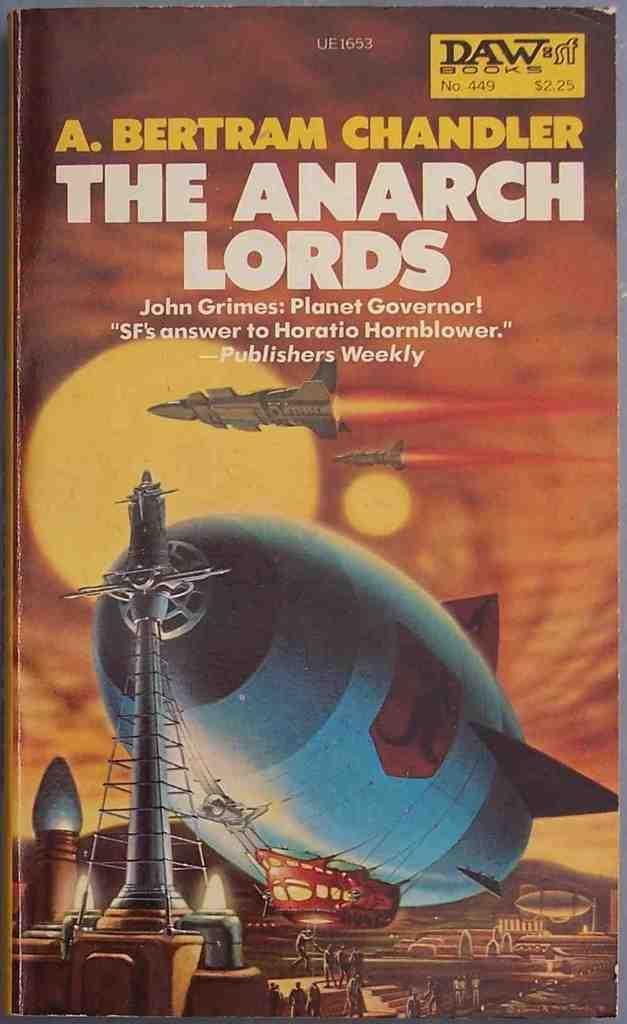<image>
Create a compact narrative representing the image presented. A paperback book called The Anarch Lords which has a picture of a zephyr and spaceships in front of 2 suns. 